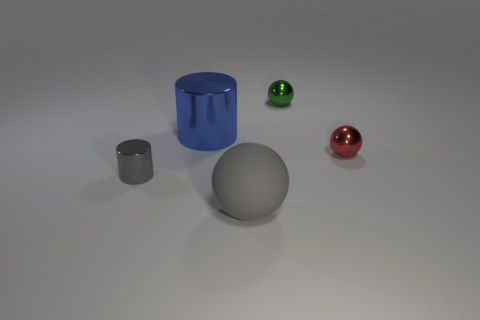Add 2 large blue cylinders. How many objects exist? 7 Subtract all cylinders. How many objects are left? 3 Subtract all red shiny things. Subtract all gray metal objects. How many objects are left? 3 Add 3 large objects. How many large objects are left? 5 Add 1 tiny gray metal objects. How many tiny gray metal objects exist? 2 Subtract 0 brown cylinders. How many objects are left? 5 